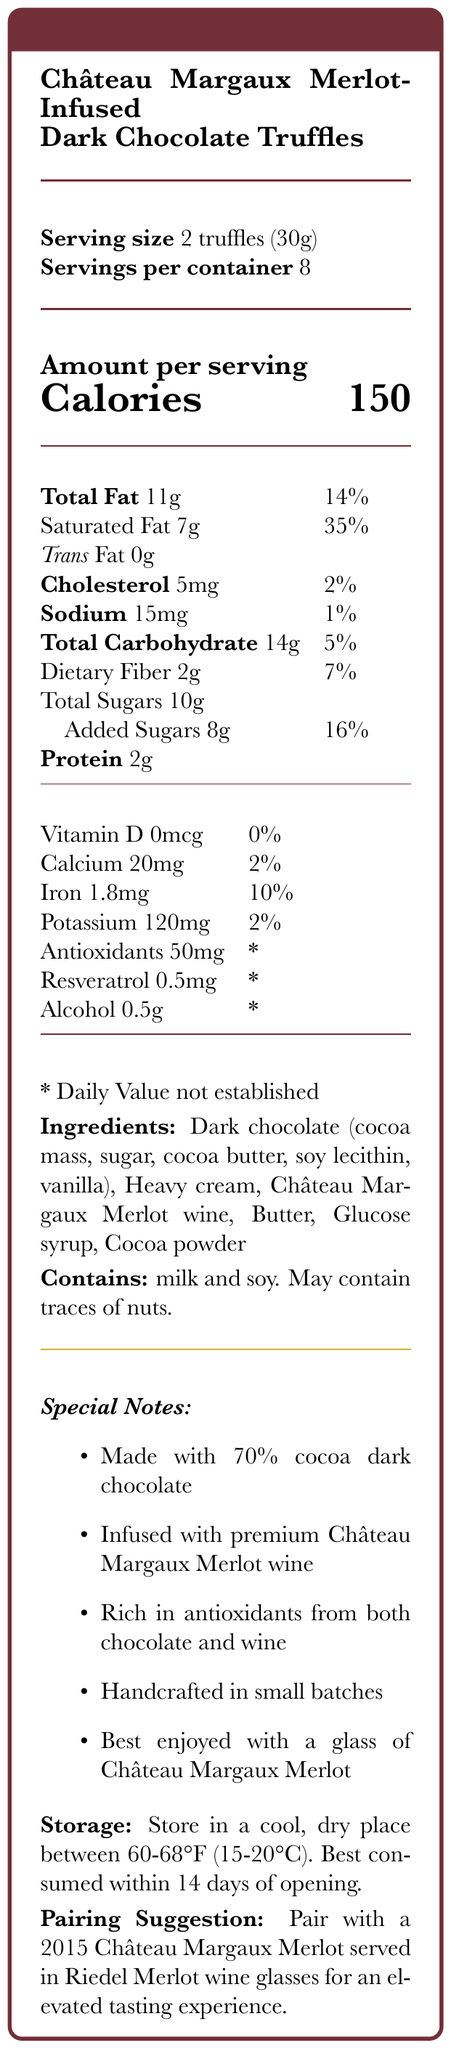what is the serving size? The serving size is clearly stated as "2 truffles (30g)" under the product name and above the number of servings per container.
Answer: 2 truffles (30g) how many calories are in one serving? The document specifies that each serving contains 150 calories, indicated under the "Amount per serving" section.
Answer: 150 what is the daily value percentage of saturated fat in a serving? Under the "Amount per serving" section, it is stated that the saturated fat content is 7g and its daily value percentage is 35%.
Answer: 35% how much protein is in each serving? The amount of protein per serving is listed as 2g in the nutritional facts table under the "Amount per serving" section.
Answer: 2g how much iron is in each serving? The nutritional facts table indicates that each serving contains 1.8mg of iron, which is 10% of the daily value.
Answer: 1.8mg what are the ingredients of the truffles? The ingredient list is provided towards the bottom of the document under "Ingredients."
Answer: Dark chocolate (cocoa mass, sugar, cocoa butter, soy lecithin, vanilla), Heavy cream, Château Margaux Merlot wine, Butter, Glucose syrup, Cocoa powder what special note is included about the chocolate? The special note section mentions that the truffles are "Made with 70% cocoa dark chocolate."
Answer: Made with 70% cocoa dark chocolate which allergens are mentioned in the document? Under the "Contains" section, it mentions that the product contains milk and soy and may contain traces of nuts.
Answer: milk and soy. May contain traces of nuts. how many servings are there per container? The document specifies that there are 8 servings per container, stated right below the serving size.
Answer: 8 what is the sodium content per serving in milligrams? The sodium content is listed in the nutritional table as 15mg per serving with a daily value of 1%.
Answer: 15mg what nuts might be present in the truffles? A. Peanuts B. Tree nuts C. Both D. None The document states, "Contains milk and soy. May contain traces of nuts," indicating tree nuts may be present.
Answer: B which of these is NOT a special note of the product? A. Made with 70% cocoa dark chocolate B. Infused with premium Château Margaux Merlot wine C. Contains no sugar D. Handcrafted in small batches The truffles are made with 70% cocoa dark chocolate, infused with premium Château Margaux Merlot wine, and handcrafted in small batches. It does not mention the chocolate is sugar-free.
Answer: C is the product rich in antioxidants? The document explicitly states in the special notes that the truffles are "Rich in antioxidants from both chocolate and wine."
Answer: Yes is there vitamin D in the truffles? The nutritional information states that the vitamin D content is 0mcg and the daily value is 0%.
Answer: No summarize the entire document. The document offers a comprehensive overview of the nutritional content, ingredients, and special features of the dark chocolate truffles along with storage and pairing recommendations.
Answer: The document provides detailed nutritional information for "Château Margaux Merlot-Infused Dark Chocolate Truffles." Each serving size is 2 truffles (30g) with 150 calories and 8 servings per container. It lists the amounts of fats, cholesterol, sodium, carbohydrates, sugars, proteins, vitamins, and minerals per serving. The ingredients include dark chocolate, heavy cream, Château Margaux Merlot wine, butter, glucose syrup, and cocoa powder. Special notes emphasize the use of 70% cocoa dark chocolate, the infusion of premium wine, its handcrafted nature, and its antioxidant content. Allergen information indicates the presence of milk and soy, with possible traces of nuts. Storage instructions and a pairing suggestion for an elevated tasting experience are also provided. how many milligrams of antioxidants are there per serving? The amount of antioxidants per serving is listed as 50mg, though the daily value percentage is not established.
Answer: 50mg what is the RDI percentage for vitamin C in this product? The document does not provide any information regarding the vitamin C content in the product.
Answer: Not enough information 